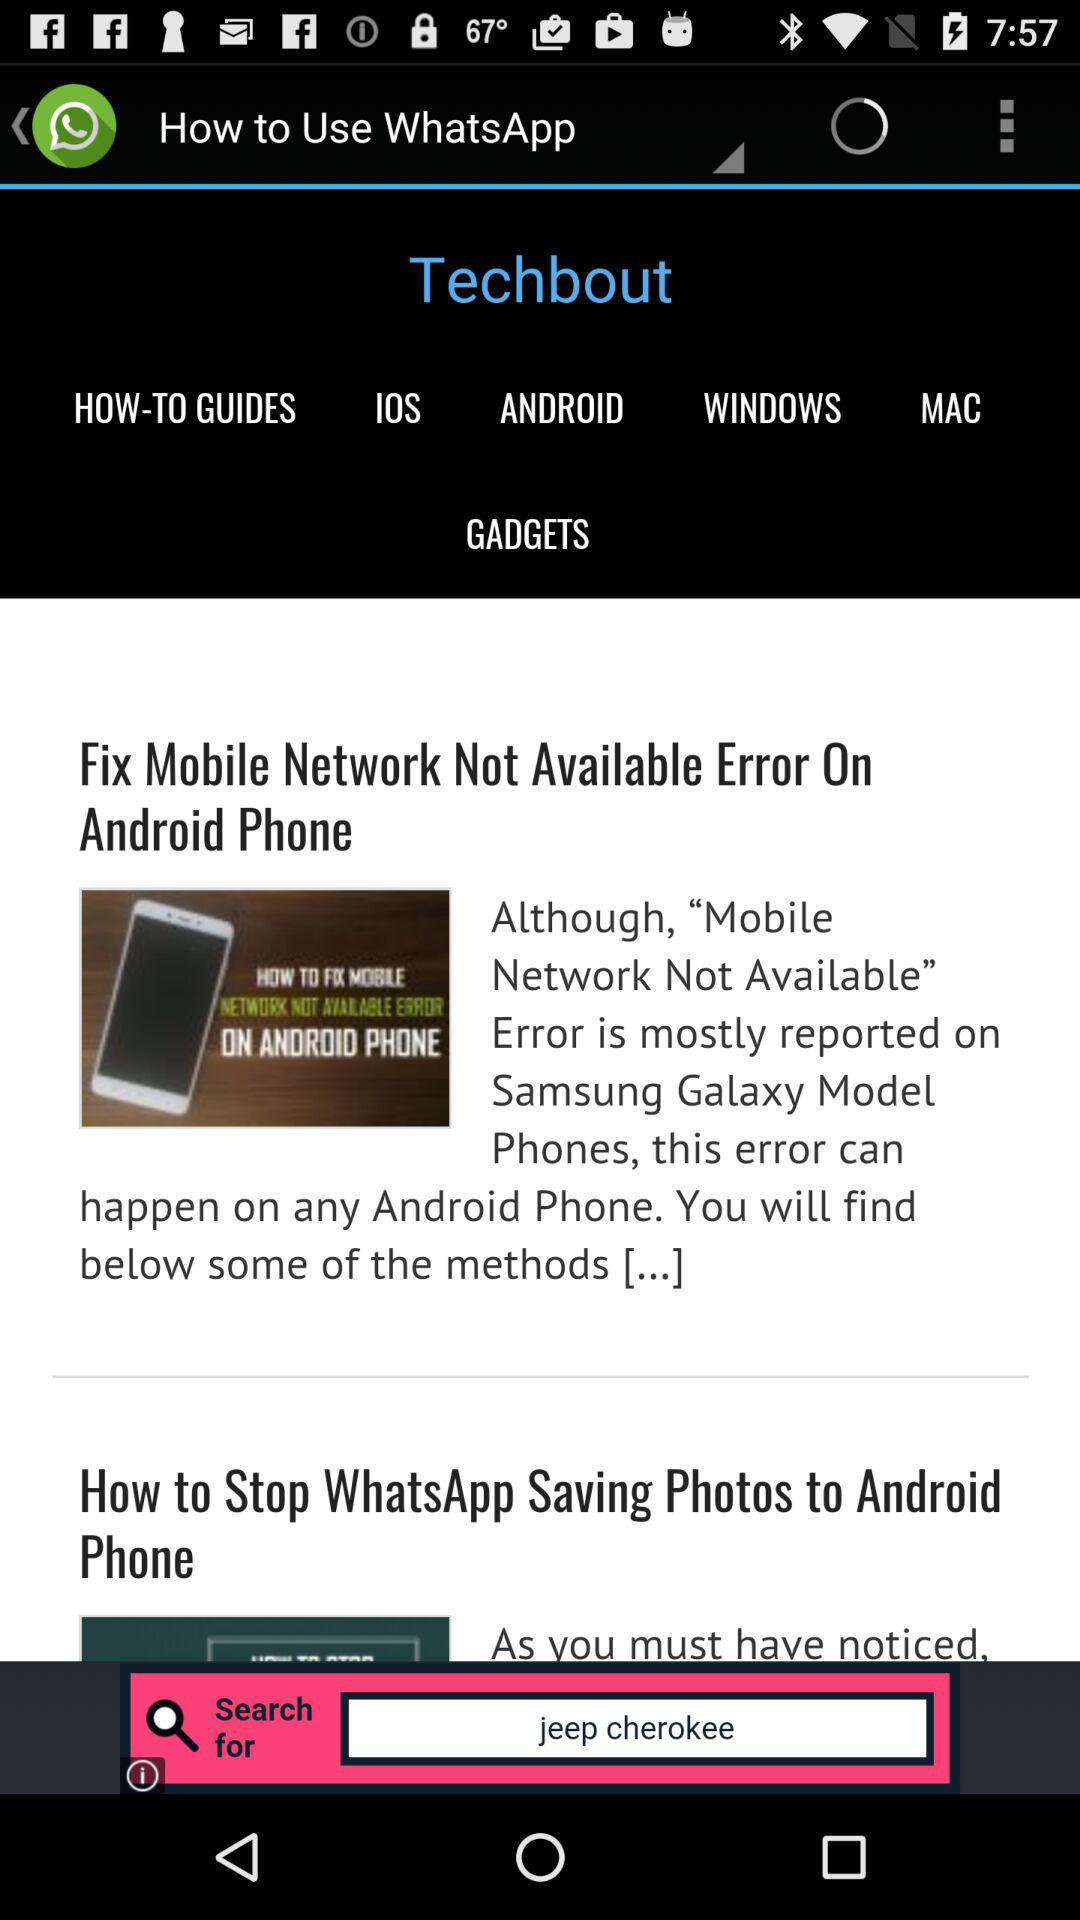What is the name of the application? The name of the application is "WhatsApp". 